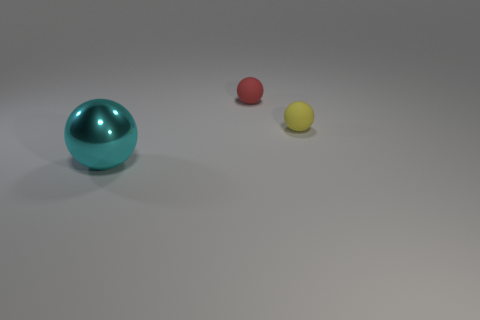Add 2 big blue rubber objects. How many objects exist? 5 Add 3 red matte objects. How many red matte objects exist? 4 Subtract 0 brown cylinders. How many objects are left? 3 Subtract all small yellow objects. Subtract all cyan metal balls. How many objects are left? 1 Add 1 small balls. How many small balls are left? 3 